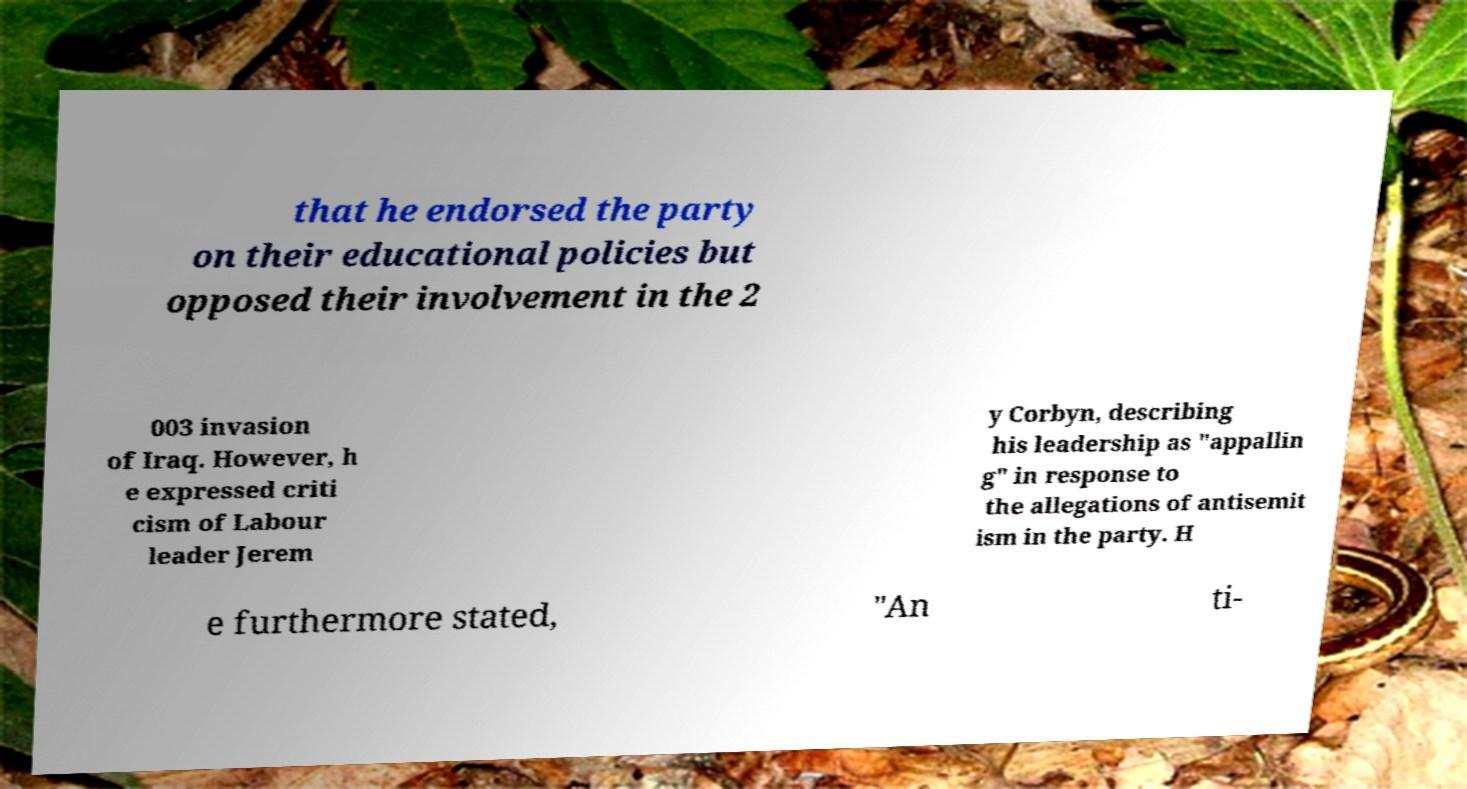Please read and relay the text visible in this image. What does it say? that he endorsed the party on their educational policies but opposed their involvement in the 2 003 invasion of Iraq. However, h e expressed criti cism of Labour leader Jerem y Corbyn, describing his leadership as "appallin g" in response to the allegations of antisemit ism in the party. H e furthermore stated, "An ti- 